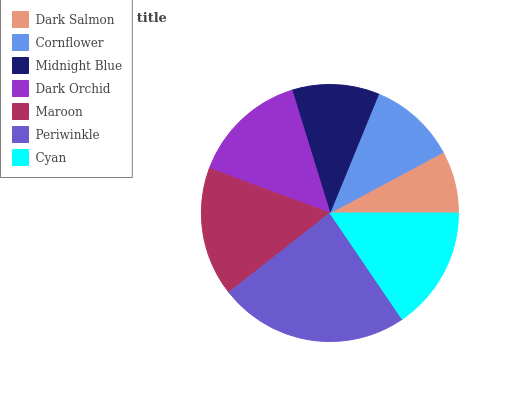Is Dark Salmon the minimum?
Answer yes or no. Yes. Is Periwinkle the maximum?
Answer yes or no. Yes. Is Cornflower the minimum?
Answer yes or no. No. Is Cornflower the maximum?
Answer yes or no. No. Is Cornflower greater than Dark Salmon?
Answer yes or no. Yes. Is Dark Salmon less than Cornflower?
Answer yes or no. Yes. Is Dark Salmon greater than Cornflower?
Answer yes or no. No. Is Cornflower less than Dark Salmon?
Answer yes or no. No. Is Dark Orchid the high median?
Answer yes or no. Yes. Is Dark Orchid the low median?
Answer yes or no. Yes. Is Dark Salmon the high median?
Answer yes or no. No. Is Maroon the low median?
Answer yes or no. No. 